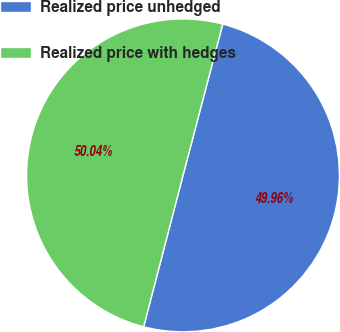Convert chart to OTSL. <chart><loc_0><loc_0><loc_500><loc_500><pie_chart><fcel>Realized price unhedged<fcel>Realized price with hedges<nl><fcel>49.96%<fcel>50.04%<nl></chart> 